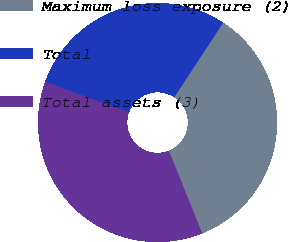<chart> <loc_0><loc_0><loc_500><loc_500><pie_chart><fcel>Maximum loss exposure (2)<fcel>Total<fcel>Total assets (3)<nl><fcel>34.66%<fcel>28.72%<fcel>36.62%<nl></chart> 